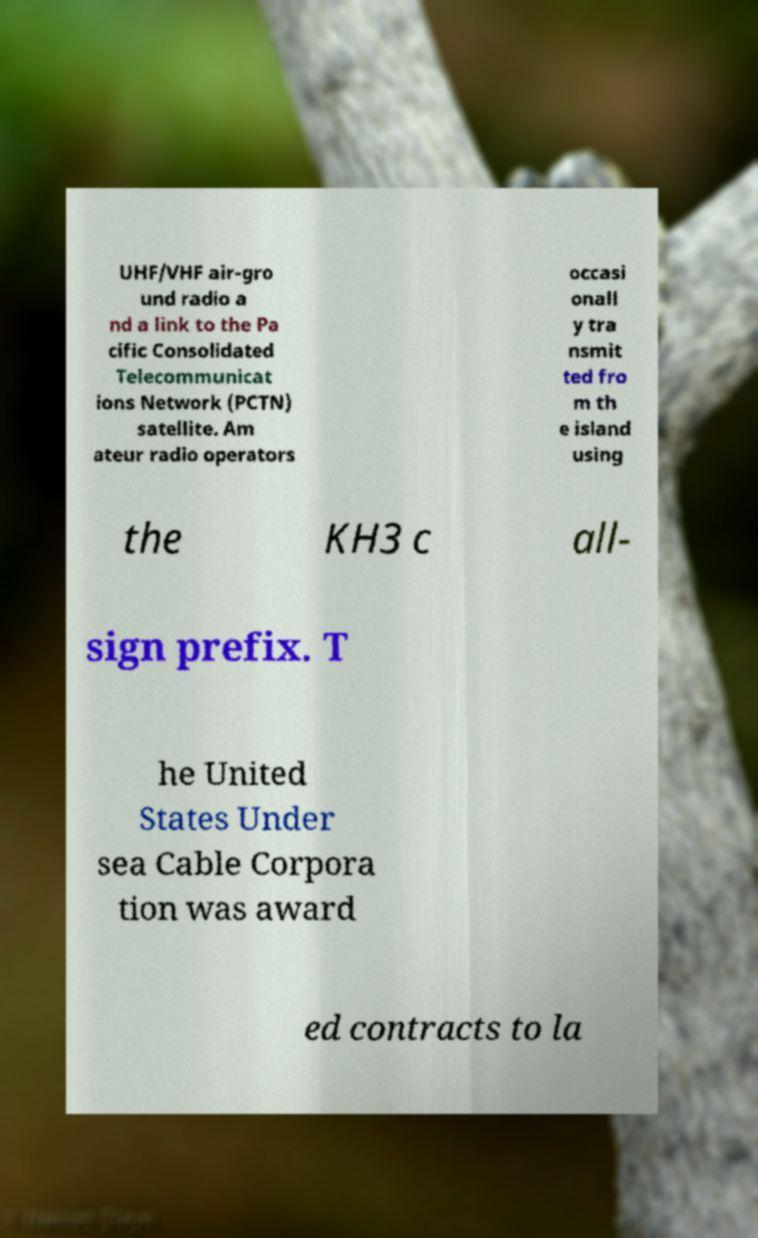Please read and relay the text visible in this image. What does it say? UHF/VHF air-gro und radio a nd a link to the Pa cific Consolidated Telecommunicat ions Network (PCTN) satellite. Am ateur radio operators occasi onall y tra nsmit ted fro m th e island using the KH3 c all- sign prefix. T he United States Under sea Cable Corpora tion was award ed contracts to la 